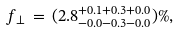Convert formula to latex. <formula><loc_0><loc_0><loc_500><loc_500>f _ { \perp } \, = \, ( 2 . 8 ^ { + 0 . 1 + 0 . 3 + 0 . 0 } _ { - 0 . 0 - 0 . 3 - 0 . 0 } ) \% ,</formula> 